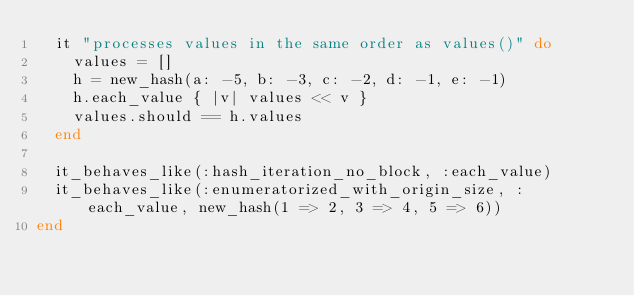<code> <loc_0><loc_0><loc_500><loc_500><_Ruby_>  it "processes values in the same order as values()" do
    values = []
    h = new_hash(a: -5, b: -3, c: -2, d: -1, e: -1)
    h.each_value { |v| values << v }
    values.should == h.values
  end

  it_behaves_like(:hash_iteration_no_block, :each_value)
  it_behaves_like(:enumeratorized_with_origin_size, :each_value, new_hash(1 => 2, 3 => 4, 5 => 6))
end
</code> 